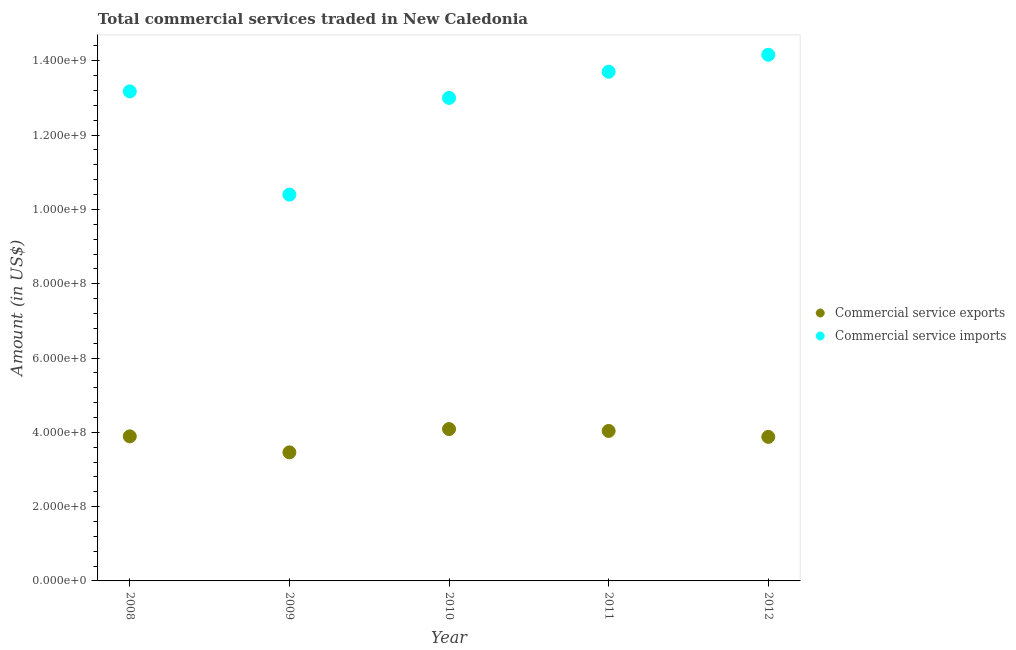Is the number of dotlines equal to the number of legend labels?
Provide a succinct answer. Yes. What is the amount of commercial service exports in 2011?
Your response must be concise. 4.04e+08. Across all years, what is the maximum amount of commercial service imports?
Give a very brief answer. 1.42e+09. Across all years, what is the minimum amount of commercial service exports?
Make the answer very short. 3.46e+08. In which year was the amount of commercial service exports maximum?
Give a very brief answer. 2010. In which year was the amount of commercial service imports minimum?
Provide a succinct answer. 2009. What is the total amount of commercial service exports in the graph?
Your response must be concise. 1.94e+09. What is the difference between the amount of commercial service exports in 2008 and that in 2010?
Provide a succinct answer. -1.97e+07. What is the difference between the amount of commercial service exports in 2011 and the amount of commercial service imports in 2012?
Make the answer very short. -1.01e+09. What is the average amount of commercial service exports per year?
Provide a short and direct response. 3.87e+08. In the year 2010, what is the difference between the amount of commercial service exports and amount of commercial service imports?
Your answer should be very brief. -8.91e+08. In how many years, is the amount of commercial service exports greater than 1400000000 US$?
Your answer should be compact. 0. What is the ratio of the amount of commercial service exports in 2008 to that in 2010?
Keep it short and to the point. 0.95. Is the amount of commercial service imports in 2011 less than that in 2012?
Give a very brief answer. Yes. Is the difference between the amount of commercial service imports in 2009 and 2012 greater than the difference between the amount of commercial service exports in 2009 and 2012?
Provide a short and direct response. No. What is the difference between the highest and the second highest amount of commercial service imports?
Ensure brevity in your answer.  4.58e+07. What is the difference between the highest and the lowest amount of commercial service imports?
Provide a short and direct response. 3.76e+08. Is the sum of the amount of commercial service imports in 2009 and 2012 greater than the maximum amount of commercial service exports across all years?
Ensure brevity in your answer.  Yes. Is the amount of commercial service exports strictly less than the amount of commercial service imports over the years?
Make the answer very short. Yes. How many years are there in the graph?
Give a very brief answer. 5. Are the values on the major ticks of Y-axis written in scientific E-notation?
Offer a terse response. Yes. Does the graph contain grids?
Your answer should be compact. No. How are the legend labels stacked?
Provide a short and direct response. Vertical. What is the title of the graph?
Give a very brief answer. Total commercial services traded in New Caledonia. What is the Amount (in US$) of Commercial service exports in 2008?
Provide a succinct answer. 3.89e+08. What is the Amount (in US$) in Commercial service imports in 2008?
Keep it short and to the point. 1.32e+09. What is the Amount (in US$) in Commercial service exports in 2009?
Provide a short and direct response. 3.46e+08. What is the Amount (in US$) in Commercial service imports in 2009?
Give a very brief answer. 1.04e+09. What is the Amount (in US$) in Commercial service exports in 2010?
Your response must be concise. 4.09e+08. What is the Amount (in US$) of Commercial service imports in 2010?
Your response must be concise. 1.30e+09. What is the Amount (in US$) in Commercial service exports in 2011?
Give a very brief answer. 4.04e+08. What is the Amount (in US$) in Commercial service imports in 2011?
Your answer should be very brief. 1.37e+09. What is the Amount (in US$) of Commercial service exports in 2012?
Provide a short and direct response. 3.88e+08. What is the Amount (in US$) of Commercial service imports in 2012?
Your answer should be compact. 1.42e+09. Across all years, what is the maximum Amount (in US$) in Commercial service exports?
Keep it short and to the point. 4.09e+08. Across all years, what is the maximum Amount (in US$) in Commercial service imports?
Offer a very short reply. 1.42e+09. Across all years, what is the minimum Amount (in US$) in Commercial service exports?
Provide a succinct answer. 3.46e+08. Across all years, what is the minimum Amount (in US$) of Commercial service imports?
Make the answer very short. 1.04e+09. What is the total Amount (in US$) in Commercial service exports in the graph?
Ensure brevity in your answer.  1.94e+09. What is the total Amount (in US$) of Commercial service imports in the graph?
Your answer should be compact. 6.44e+09. What is the difference between the Amount (in US$) in Commercial service exports in 2008 and that in 2009?
Provide a short and direct response. 4.31e+07. What is the difference between the Amount (in US$) of Commercial service imports in 2008 and that in 2009?
Make the answer very short. 2.78e+08. What is the difference between the Amount (in US$) in Commercial service exports in 2008 and that in 2010?
Provide a short and direct response. -1.97e+07. What is the difference between the Amount (in US$) in Commercial service imports in 2008 and that in 2010?
Ensure brevity in your answer.  1.75e+07. What is the difference between the Amount (in US$) in Commercial service exports in 2008 and that in 2011?
Your answer should be compact. -1.45e+07. What is the difference between the Amount (in US$) of Commercial service imports in 2008 and that in 2011?
Offer a very short reply. -5.29e+07. What is the difference between the Amount (in US$) of Commercial service exports in 2008 and that in 2012?
Provide a short and direct response. 1.44e+06. What is the difference between the Amount (in US$) of Commercial service imports in 2008 and that in 2012?
Provide a short and direct response. -9.86e+07. What is the difference between the Amount (in US$) in Commercial service exports in 2009 and that in 2010?
Provide a short and direct response. -6.27e+07. What is the difference between the Amount (in US$) of Commercial service imports in 2009 and that in 2010?
Offer a terse response. -2.60e+08. What is the difference between the Amount (in US$) in Commercial service exports in 2009 and that in 2011?
Your response must be concise. -5.76e+07. What is the difference between the Amount (in US$) in Commercial service imports in 2009 and that in 2011?
Offer a terse response. -3.31e+08. What is the difference between the Amount (in US$) of Commercial service exports in 2009 and that in 2012?
Make the answer very short. -4.16e+07. What is the difference between the Amount (in US$) in Commercial service imports in 2009 and that in 2012?
Your answer should be compact. -3.76e+08. What is the difference between the Amount (in US$) of Commercial service exports in 2010 and that in 2011?
Provide a short and direct response. 5.13e+06. What is the difference between the Amount (in US$) of Commercial service imports in 2010 and that in 2011?
Offer a very short reply. -7.04e+07. What is the difference between the Amount (in US$) in Commercial service exports in 2010 and that in 2012?
Your answer should be very brief. 2.11e+07. What is the difference between the Amount (in US$) of Commercial service imports in 2010 and that in 2012?
Provide a short and direct response. -1.16e+08. What is the difference between the Amount (in US$) in Commercial service exports in 2011 and that in 2012?
Keep it short and to the point. 1.60e+07. What is the difference between the Amount (in US$) in Commercial service imports in 2011 and that in 2012?
Provide a succinct answer. -4.58e+07. What is the difference between the Amount (in US$) of Commercial service exports in 2008 and the Amount (in US$) of Commercial service imports in 2009?
Offer a terse response. -6.51e+08. What is the difference between the Amount (in US$) of Commercial service exports in 2008 and the Amount (in US$) of Commercial service imports in 2010?
Offer a terse response. -9.11e+08. What is the difference between the Amount (in US$) of Commercial service exports in 2008 and the Amount (in US$) of Commercial service imports in 2011?
Give a very brief answer. -9.81e+08. What is the difference between the Amount (in US$) in Commercial service exports in 2008 and the Amount (in US$) in Commercial service imports in 2012?
Provide a short and direct response. -1.03e+09. What is the difference between the Amount (in US$) in Commercial service exports in 2009 and the Amount (in US$) in Commercial service imports in 2010?
Offer a terse response. -9.54e+08. What is the difference between the Amount (in US$) in Commercial service exports in 2009 and the Amount (in US$) in Commercial service imports in 2011?
Your response must be concise. -1.02e+09. What is the difference between the Amount (in US$) of Commercial service exports in 2009 and the Amount (in US$) of Commercial service imports in 2012?
Give a very brief answer. -1.07e+09. What is the difference between the Amount (in US$) of Commercial service exports in 2010 and the Amount (in US$) of Commercial service imports in 2011?
Ensure brevity in your answer.  -9.62e+08. What is the difference between the Amount (in US$) in Commercial service exports in 2010 and the Amount (in US$) in Commercial service imports in 2012?
Give a very brief answer. -1.01e+09. What is the difference between the Amount (in US$) in Commercial service exports in 2011 and the Amount (in US$) in Commercial service imports in 2012?
Offer a very short reply. -1.01e+09. What is the average Amount (in US$) of Commercial service exports per year?
Provide a succinct answer. 3.87e+08. What is the average Amount (in US$) in Commercial service imports per year?
Provide a succinct answer. 1.29e+09. In the year 2008, what is the difference between the Amount (in US$) of Commercial service exports and Amount (in US$) of Commercial service imports?
Your answer should be very brief. -9.29e+08. In the year 2009, what is the difference between the Amount (in US$) of Commercial service exports and Amount (in US$) of Commercial service imports?
Give a very brief answer. -6.94e+08. In the year 2010, what is the difference between the Amount (in US$) in Commercial service exports and Amount (in US$) in Commercial service imports?
Offer a terse response. -8.91e+08. In the year 2011, what is the difference between the Amount (in US$) of Commercial service exports and Amount (in US$) of Commercial service imports?
Your answer should be compact. -9.67e+08. In the year 2012, what is the difference between the Amount (in US$) of Commercial service exports and Amount (in US$) of Commercial service imports?
Give a very brief answer. -1.03e+09. What is the ratio of the Amount (in US$) of Commercial service exports in 2008 to that in 2009?
Your answer should be compact. 1.12. What is the ratio of the Amount (in US$) of Commercial service imports in 2008 to that in 2009?
Make the answer very short. 1.27. What is the ratio of the Amount (in US$) of Commercial service exports in 2008 to that in 2010?
Ensure brevity in your answer.  0.95. What is the ratio of the Amount (in US$) in Commercial service imports in 2008 to that in 2010?
Provide a succinct answer. 1.01. What is the ratio of the Amount (in US$) in Commercial service exports in 2008 to that in 2011?
Offer a very short reply. 0.96. What is the ratio of the Amount (in US$) in Commercial service imports in 2008 to that in 2011?
Your answer should be compact. 0.96. What is the ratio of the Amount (in US$) of Commercial service exports in 2008 to that in 2012?
Provide a short and direct response. 1. What is the ratio of the Amount (in US$) in Commercial service imports in 2008 to that in 2012?
Ensure brevity in your answer.  0.93. What is the ratio of the Amount (in US$) in Commercial service exports in 2009 to that in 2010?
Give a very brief answer. 0.85. What is the ratio of the Amount (in US$) in Commercial service imports in 2009 to that in 2010?
Provide a short and direct response. 0.8. What is the ratio of the Amount (in US$) of Commercial service exports in 2009 to that in 2011?
Make the answer very short. 0.86. What is the ratio of the Amount (in US$) in Commercial service imports in 2009 to that in 2011?
Keep it short and to the point. 0.76. What is the ratio of the Amount (in US$) of Commercial service exports in 2009 to that in 2012?
Offer a terse response. 0.89. What is the ratio of the Amount (in US$) in Commercial service imports in 2009 to that in 2012?
Offer a terse response. 0.73. What is the ratio of the Amount (in US$) in Commercial service exports in 2010 to that in 2011?
Provide a short and direct response. 1.01. What is the ratio of the Amount (in US$) in Commercial service imports in 2010 to that in 2011?
Ensure brevity in your answer.  0.95. What is the ratio of the Amount (in US$) in Commercial service exports in 2010 to that in 2012?
Provide a short and direct response. 1.05. What is the ratio of the Amount (in US$) of Commercial service imports in 2010 to that in 2012?
Your response must be concise. 0.92. What is the ratio of the Amount (in US$) in Commercial service exports in 2011 to that in 2012?
Ensure brevity in your answer.  1.04. What is the difference between the highest and the second highest Amount (in US$) in Commercial service exports?
Give a very brief answer. 5.13e+06. What is the difference between the highest and the second highest Amount (in US$) in Commercial service imports?
Provide a succinct answer. 4.58e+07. What is the difference between the highest and the lowest Amount (in US$) of Commercial service exports?
Keep it short and to the point. 6.27e+07. What is the difference between the highest and the lowest Amount (in US$) in Commercial service imports?
Offer a terse response. 3.76e+08. 